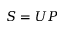Convert formula to latex. <formula><loc_0><loc_0><loc_500><loc_500>S = U P</formula> 